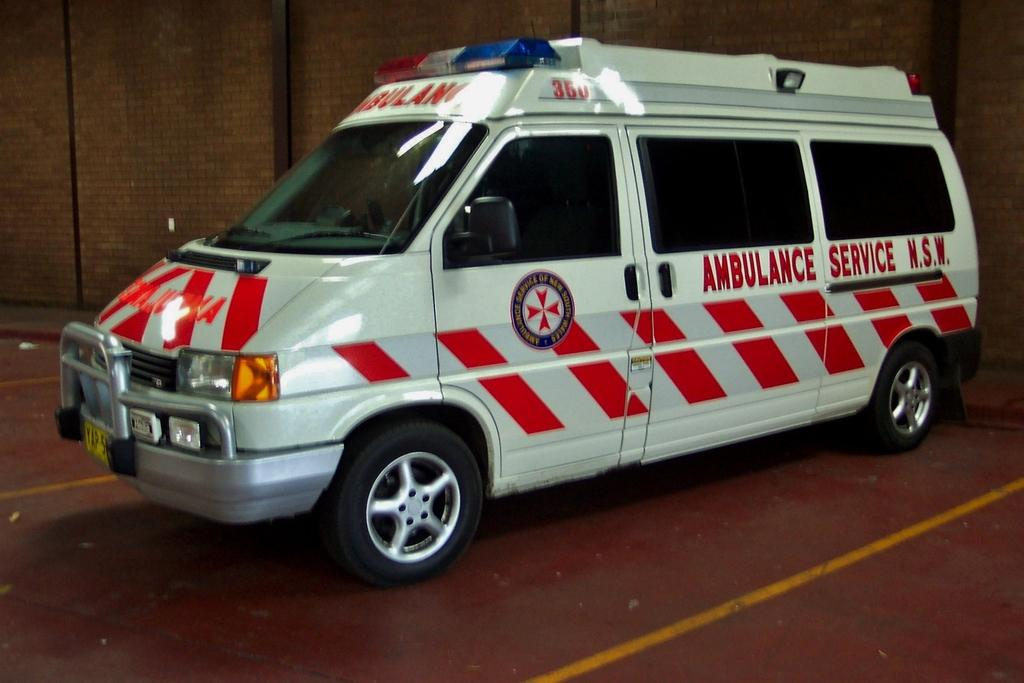<image>
Create a compact narrative representing the image presented. An ambulance says N.S.W. on the side and has red stripes. 